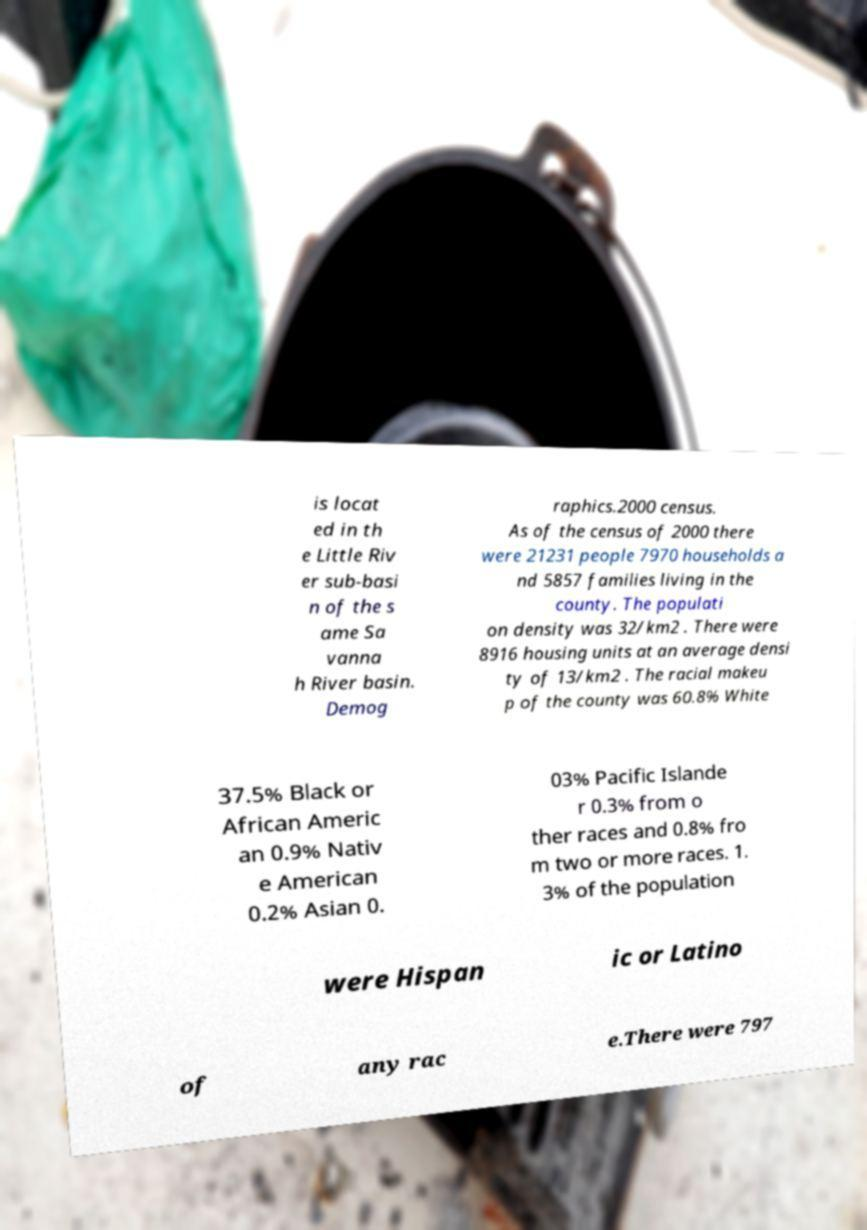What messages or text are displayed in this image? I need them in a readable, typed format. is locat ed in th e Little Riv er sub-basi n of the s ame Sa vanna h River basin. Demog raphics.2000 census. As of the census of 2000 there were 21231 people 7970 households a nd 5857 families living in the county. The populati on density was 32/km2 . There were 8916 housing units at an average densi ty of 13/km2 . The racial makeu p of the county was 60.8% White 37.5% Black or African Americ an 0.9% Nativ e American 0.2% Asian 0. 03% Pacific Islande r 0.3% from o ther races and 0.8% fro m two or more races. 1. 3% of the population were Hispan ic or Latino of any rac e.There were 797 